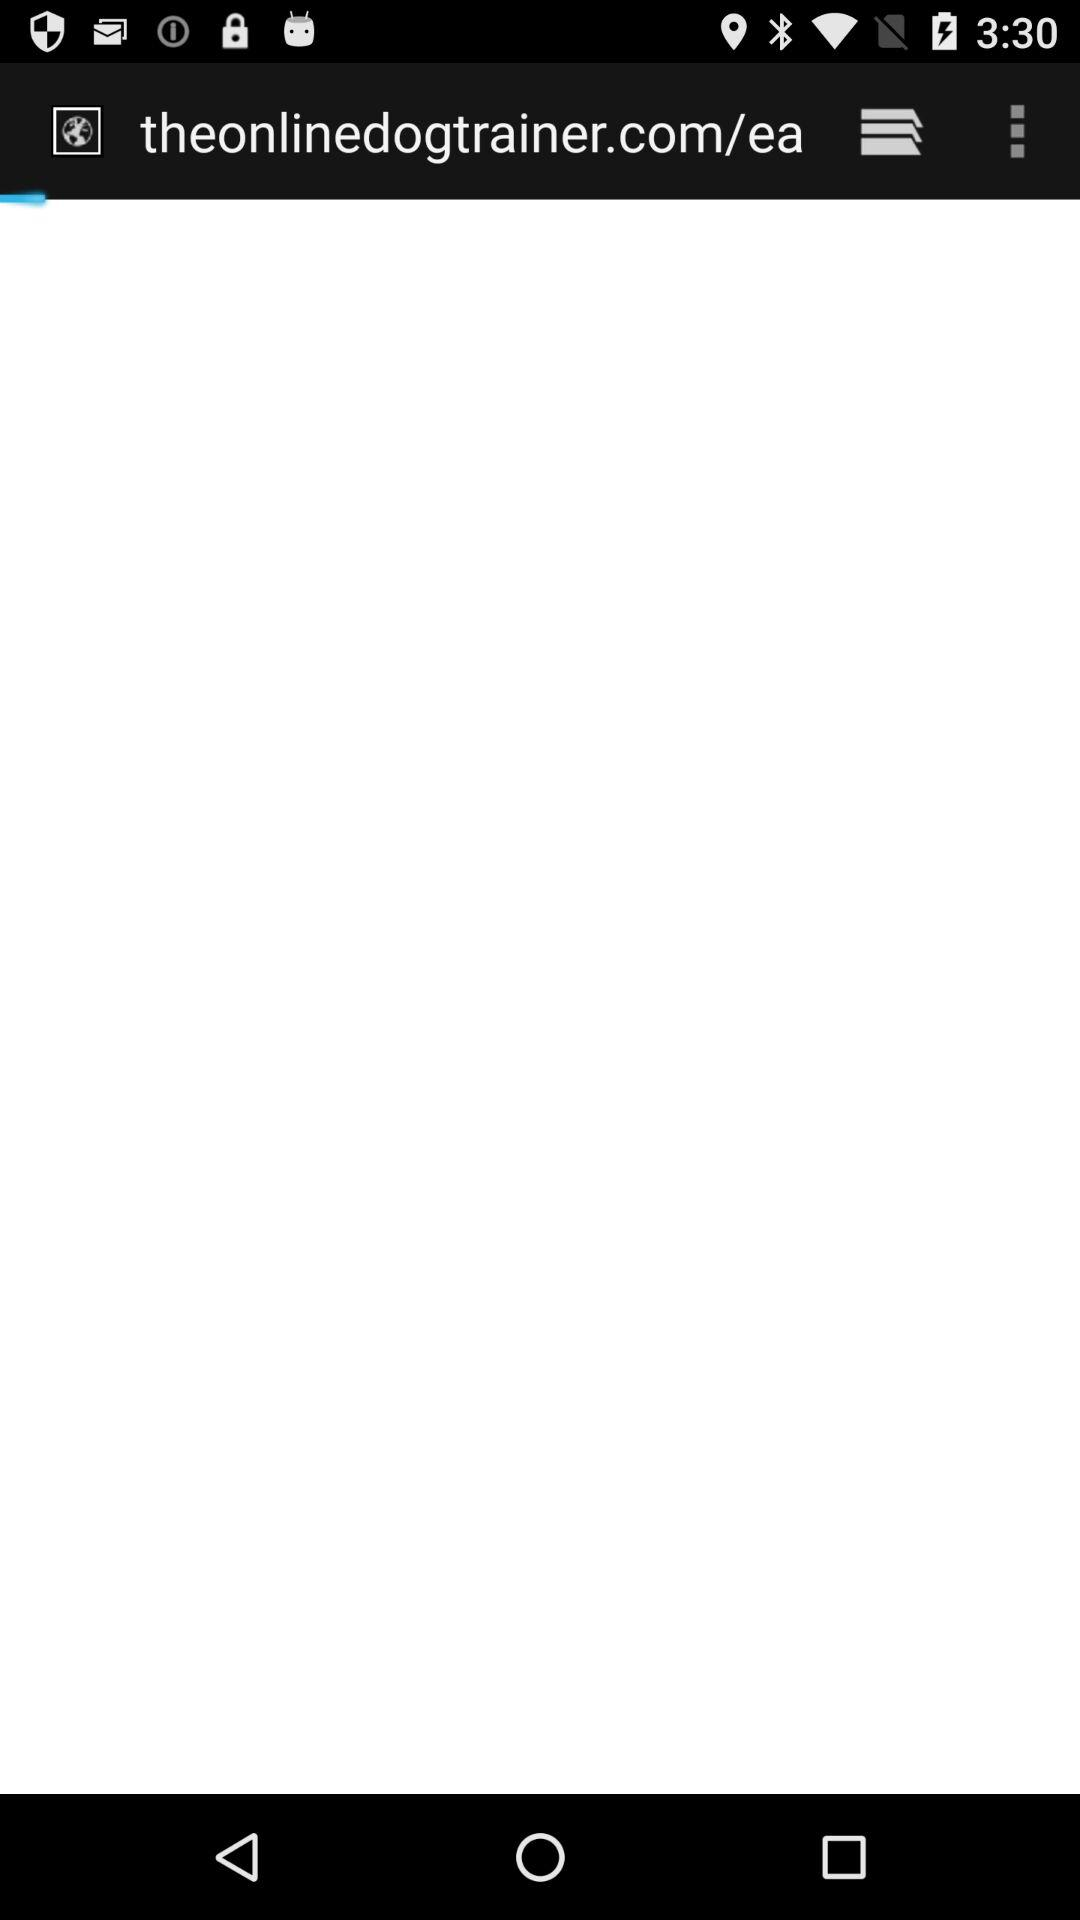What is the name of the website? The name of the website is theonlinedogtrainer.com. 